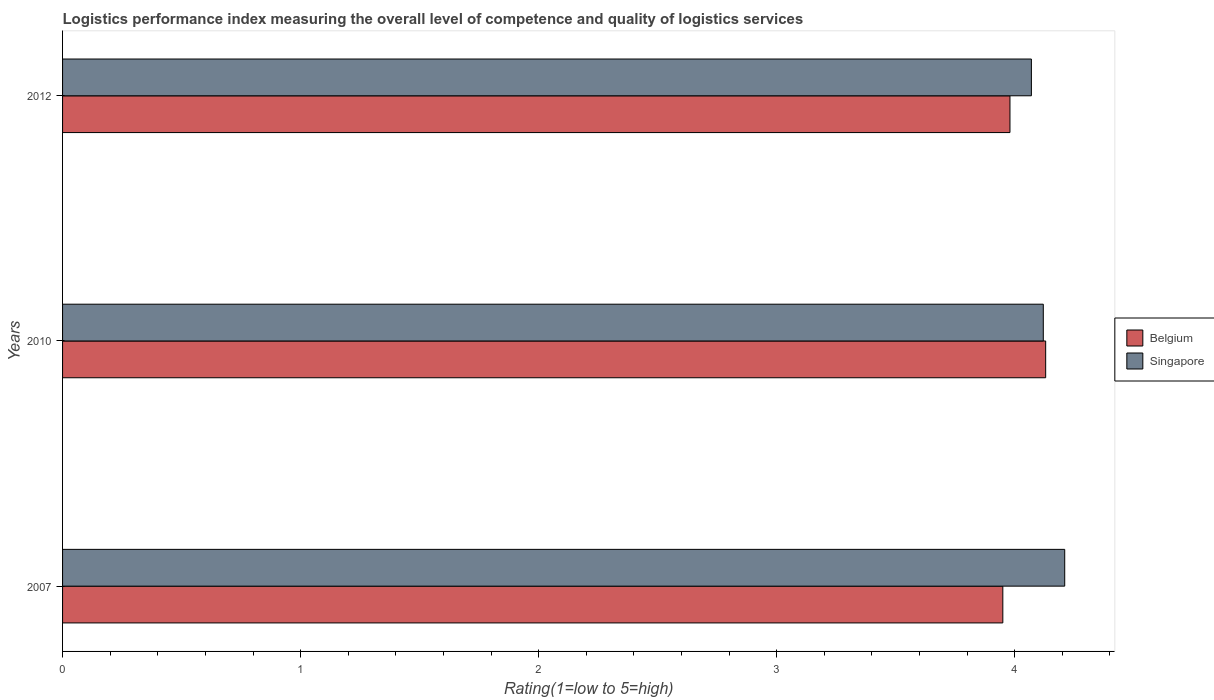Are the number of bars per tick equal to the number of legend labels?
Your answer should be very brief. Yes. Are the number of bars on each tick of the Y-axis equal?
Give a very brief answer. Yes. How many bars are there on the 1st tick from the top?
Provide a short and direct response. 2. What is the label of the 3rd group of bars from the top?
Make the answer very short. 2007. What is the Logistic performance index in Singapore in 2012?
Ensure brevity in your answer.  4.07. Across all years, what is the maximum Logistic performance index in Belgium?
Your answer should be very brief. 4.13. Across all years, what is the minimum Logistic performance index in Belgium?
Offer a terse response. 3.95. In which year was the Logistic performance index in Singapore maximum?
Offer a terse response. 2007. In which year was the Logistic performance index in Singapore minimum?
Offer a terse response. 2012. What is the total Logistic performance index in Belgium in the graph?
Your response must be concise. 12.06. What is the difference between the Logistic performance index in Belgium in 2007 and that in 2012?
Provide a short and direct response. -0.03. What is the difference between the Logistic performance index in Singapore in 2010 and the Logistic performance index in Belgium in 2012?
Make the answer very short. 0.14. What is the average Logistic performance index in Singapore per year?
Provide a succinct answer. 4.13. In the year 2012, what is the difference between the Logistic performance index in Singapore and Logistic performance index in Belgium?
Offer a terse response. 0.09. What is the ratio of the Logistic performance index in Belgium in 2007 to that in 2012?
Ensure brevity in your answer.  0.99. Is the Logistic performance index in Belgium in 2007 less than that in 2010?
Your answer should be very brief. Yes. Is the difference between the Logistic performance index in Singapore in 2007 and 2012 greater than the difference between the Logistic performance index in Belgium in 2007 and 2012?
Your response must be concise. Yes. What is the difference between the highest and the second highest Logistic performance index in Singapore?
Your answer should be very brief. 0.09. What is the difference between the highest and the lowest Logistic performance index in Belgium?
Your answer should be compact. 0.18. What does the 1st bar from the bottom in 2007 represents?
Provide a short and direct response. Belgium. What is the difference between two consecutive major ticks on the X-axis?
Your response must be concise. 1. Are the values on the major ticks of X-axis written in scientific E-notation?
Offer a very short reply. No. Does the graph contain grids?
Offer a very short reply. No. How many legend labels are there?
Your answer should be compact. 2. How are the legend labels stacked?
Give a very brief answer. Vertical. What is the title of the graph?
Your answer should be compact. Logistics performance index measuring the overall level of competence and quality of logistics services. What is the label or title of the X-axis?
Keep it short and to the point. Rating(1=low to 5=high). What is the label or title of the Y-axis?
Keep it short and to the point. Years. What is the Rating(1=low to 5=high) in Belgium in 2007?
Your answer should be very brief. 3.95. What is the Rating(1=low to 5=high) of Singapore in 2007?
Keep it short and to the point. 4.21. What is the Rating(1=low to 5=high) in Belgium in 2010?
Ensure brevity in your answer.  4.13. What is the Rating(1=low to 5=high) in Singapore in 2010?
Ensure brevity in your answer.  4.12. What is the Rating(1=low to 5=high) of Belgium in 2012?
Keep it short and to the point. 3.98. What is the Rating(1=low to 5=high) of Singapore in 2012?
Offer a very short reply. 4.07. Across all years, what is the maximum Rating(1=low to 5=high) in Belgium?
Ensure brevity in your answer.  4.13. Across all years, what is the maximum Rating(1=low to 5=high) of Singapore?
Your answer should be very brief. 4.21. Across all years, what is the minimum Rating(1=low to 5=high) in Belgium?
Your answer should be compact. 3.95. Across all years, what is the minimum Rating(1=low to 5=high) in Singapore?
Offer a very short reply. 4.07. What is the total Rating(1=low to 5=high) of Belgium in the graph?
Provide a succinct answer. 12.06. What is the difference between the Rating(1=low to 5=high) of Belgium in 2007 and that in 2010?
Your response must be concise. -0.18. What is the difference between the Rating(1=low to 5=high) in Singapore in 2007 and that in 2010?
Your response must be concise. 0.09. What is the difference between the Rating(1=low to 5=high) of Belgium in 2007 and that in 2012?
Ensure brevity in your answer.  -0.03. What is the difference between the Rating(1=low to 5=high) of Singapore in 2007 and that in 2012?
Make the answer very short. 0.14. What is the difference between the Rating(1=low to 5=high) of Belgium in 2007 and the Rating(1=low to 5=high) of Singapore in 2010?
Offer a terse response. -0.17. What is the difference between the Rating(1=low to 5=high) of Belgium in 2007 and the Rating(1=low to 5=high) of Singapore in 2012?
Your answer should be very brief. -0.12. What is the difference between the Rating(1=low to 5=high) in Belgium in 2010 and the Rating(1=low to 5=high) in Singapore in 2012?
Keep it short and to the point. 0.06. What is the average Rating(1=low to 5=high) of Belgium per year?
Keep it short and to the point. 4.02. What is the average Rating(1=low to 5=high) in Singapore per year?
Offer a terse response. 4.13. In the year 2007, what is the difference between the Rating(1=low to 5=high) in Belgium and Rating(1=low to 5=high) in Singapore?
Keep it short and to the point. -0.26. In the year 2010, what is the difference between the Rating(1=low to 5=high) in Belgium and Rating(1=low to 5=high) in Singapore?
Offer a terse response. 0.01. In the year 2012, what is the difference between the Rating(1=low to 5=high) in Belgium and Rating(1=low to 5=high) in Singapore?
Give a very brief answer. -0.09. What is the ratio of the Rating(1=low to 5=high) of Belgium in 2007 to that in 2010?
Your answer should be compact. 0.96. What is the ratio of the Rating(1=low to 5=high) in Singapore in 2007 to that in 2010?
Make the answer very short. 1.02. What is the ratio of the Rating(1=low to 5=high) in Singapore in 2007 to that in 2012?
Provide a short and direct response. 1.03. What is the ratio of the Rating(1=low to 5=high) in Belgium in 2010 to that in 2012?
Ensure brevity in your answer.  1.04. What is the ratio of the Rating(1=low to 5=high) of Singapore in 2010 to that in 2012?
Provide a short and direct response. 1.01. What is the difference between the highest and the second highest Rating(1=low to 5=high) of Singapore?
Make the answer very short. 0.09. What is the difference between the highest and the lowest Rating(1=low to 5=high) of Belgium?
Your answer should be compact. 0.18. What is the difference between the highest and the lowest Rating(1=low to 5=high) of Singapore?
Provide a short and direct response. 0.14. 